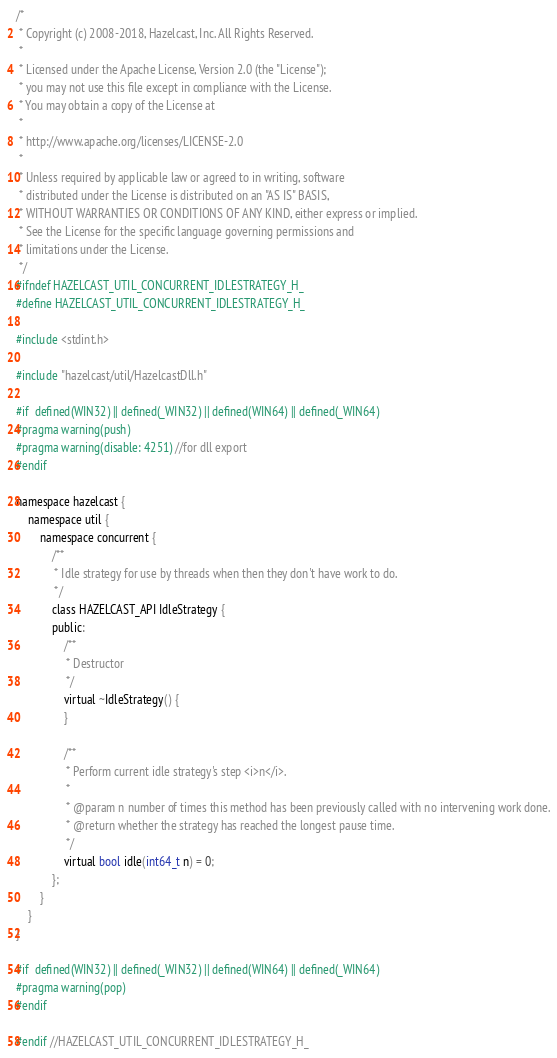Convert code to text. <code><loc_0><loc_0><loc_500><loc_500><_C_>/*
 * Copyright (c) 2008-2018, Hazelcast, Inc. All Rights Reserved.
 *
 * Licensed under the Apache License, Version 2.0 (the "License");
 * you may not use this file except in compliance with the License.
 * You may obtain a copy of the License at
 *
 * http://www.apache.org/licenses/LICENSE-2.0
 *
 * Unless required by applicable law or agreed to in writing, software
 * distributed under the License is distributed on an "AS IS" BASIS,
 * WITHOUT WARRANTIES OR CONDITIONS OF ANY KIND, either express or implied.
 * See the License for the specific language governing permissions and
 * limitations under the License.
 */
#ifndef HAZELCAST_UTIL_CONCURRENT_IDLESTRATEGY_H_
#define HAZELCAST_UTIL_CONCURRENT_IDLESTRATEGY_H_

#include <stdint.h>

#include "hazelcast/util/HazelcastDll.h"

#if  defined(WIN32) || defined(_WIN32) || defined(WIN64) || defined(_WIN64)
#pragma warning(push)
#pragma warning(disable: 4251) //for dll export
#endif

namespace hazelcast {
    namespace util {
        namespace concurrent {
            /**
             * Idle strategy for use by threads when then they don't have work to do.
             */
            class HAZELCAST_API IdleStrategy {
            public:
                /**
                 * Destructor
                 */
                virtual ~IdleStrategy() {
                }

                /**
                 * Perform current idle strategy's step <i>n</i>.
                 *
                 * @param n number of times this method has been previously called with no intervening work done.
                 * @return whether the strategy has reached the longest pause time.
                 */
                virtual bool idle(int64_t n) = 0;
            };
        }
    }
}

#if  defined(WIN32) || defined(_WIN32) || defined(WIN64) || defined(_WIN64)
#pragma warning(pop)
#endif

#endif //HAZELCAST_UTIL_CONCURRENT_IDLESTRATEGY_H_
</code> 